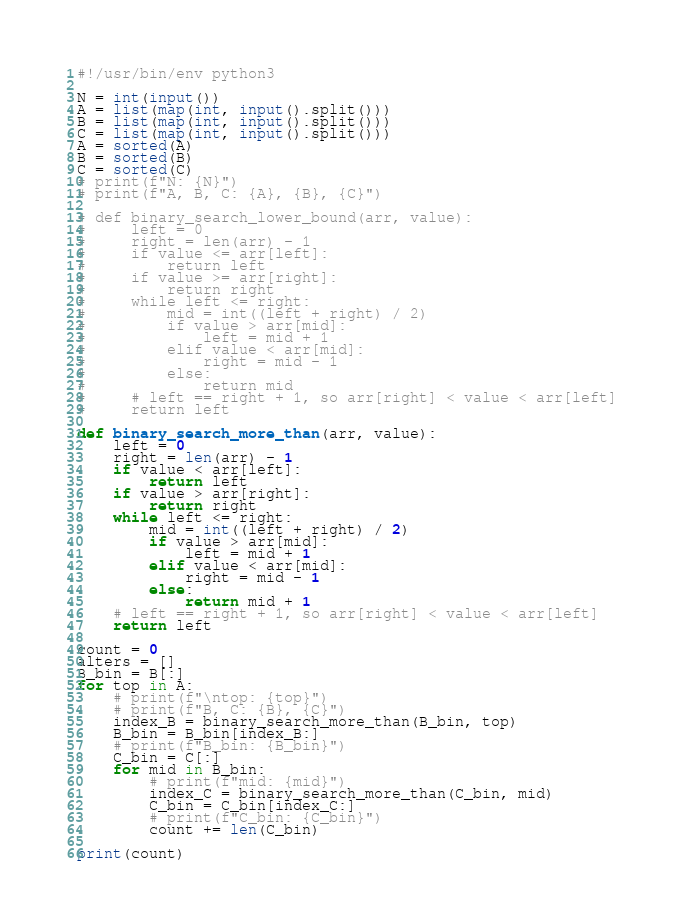<code> <loc_0><loc_0><loc_500><loc_500><_Python_>#!/usr/bin/env python3

N = int(input())
A = list(map(int, input().split()))
B = list(map(int, input().split()))
C = list(map(int, input().split()))
A = sorted(A)
B = sorted(B)
C = sorted(C)
# print(f"N: {N}")
# print(f"A, B, C: {A}, {B}, {C}")

# def binary_search_lower_bound(arr, value):
#     left = 0
#     right = len(arr) - 1
#     if value <= arr[left]:
#         return left
#     if value >= arr[right]:
#         return right
#     while left <= right:
#         mid = int((left + right) / 2)
#         if value > arr[mid]:
#             left = mid + 1
#         elif value < arr[mid]:
#             right = mid - 1
#         else:
#             return mid
#     # left == right + 1, so arr[right] < value < arr[left]
#     return left

def binary_search_more_than(arr, value):
    left = 0
    right = len(arr) - 1
    if value < arr[left]:
        return left
    if value > arr[right]:
        return right
    while left <= right:
        mid = int((left + right) / 2)
        if value > arr[mid]:
            left = mid + 1
        elif value < arr[mid]:
            right = mid - 1
        else:
            return mid + 1
    # left == right + 1, so arr[right] < value < arr[left]
    return left

count = 0
alters = []
B_bin = B[:]
for top in A:
    # print(f"\ntop: {top}")
    # print(f"B, C: {B}, {C}")
    index_B = binary_search_more_than(B_bin, top)
    B_bin = B_bin[index_B:]
    # print(f"B_bin: {B_bin}")
    C_bin = C[:]
    for mid in B_bin:
        # print(f"mid: {mid}")
        index_C = binary_search_more_than(C_bin, mid)
        C_bin = C_bin[index_C:]
        # print(f"C_bin: {C_bin}")
        count += len(C_bin)

print(count)
</code> 